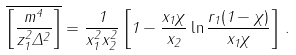<formula> <loc_0><loc_0><loc_500><loc_500>\overline { \left [ \frac { m ^ { 4 } } { z _ { 1 } ^ { 2 } \Delta ^ { 2 } } \right ] } = \frac { 1 } { x _ { 1 } ^ { 2 } x _ { 2 } ^ { 2 } } \left [ 1 - \frac { x _ { 1 } \chi } { x _ { 2 } } \ln \frac { r _ { 1 } ( 1 - \chi ) } { x _ { 1 } \chi } \right ] \, .</formula> 